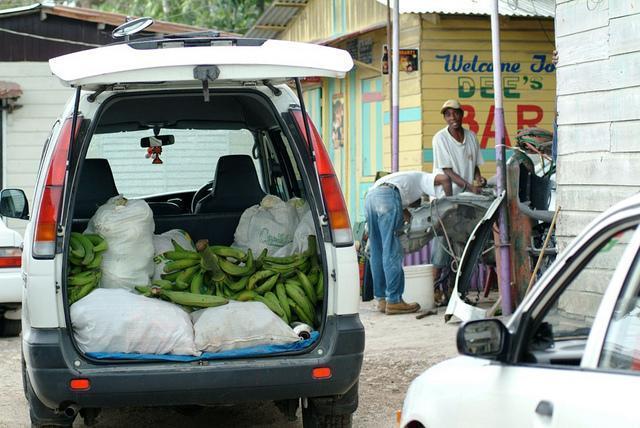How many bananas can you see?
Give a very brief answer. 2. How many cars are in the picture?
Give a very brief answer. 2. How many trucks are there?
Give a very brief answer. 2. How many people are there?
Give a very brief answer. 2. How many pizzas are shown?
Give a very brief answer. 0. 